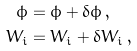<formula> <loc_0><loc_0><loc_500><loc_500>\phi & = \bar { \phi } + \delta \phi \, , \\ W _ { i } & = \bar { W } _ { i } + \delta W _ { i } \, ,</formula> 